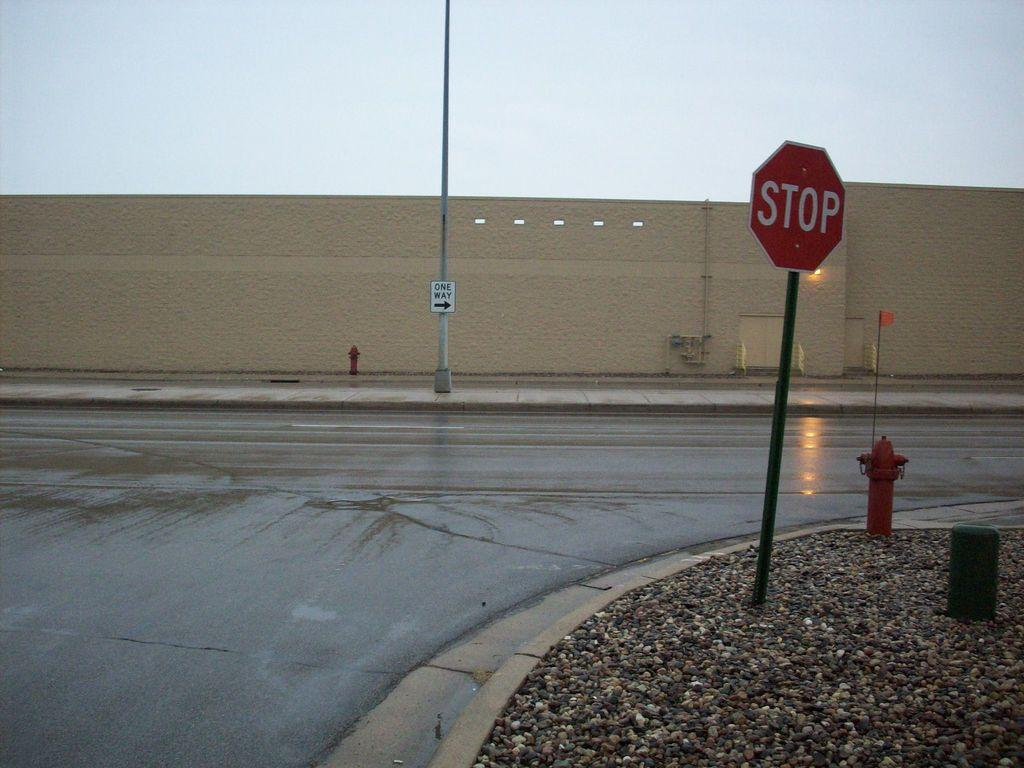<image>
Write a terse but informative summary of the picture. A lone stop sign stands on a lonely and wet intersection with a long industrial wall in the background 